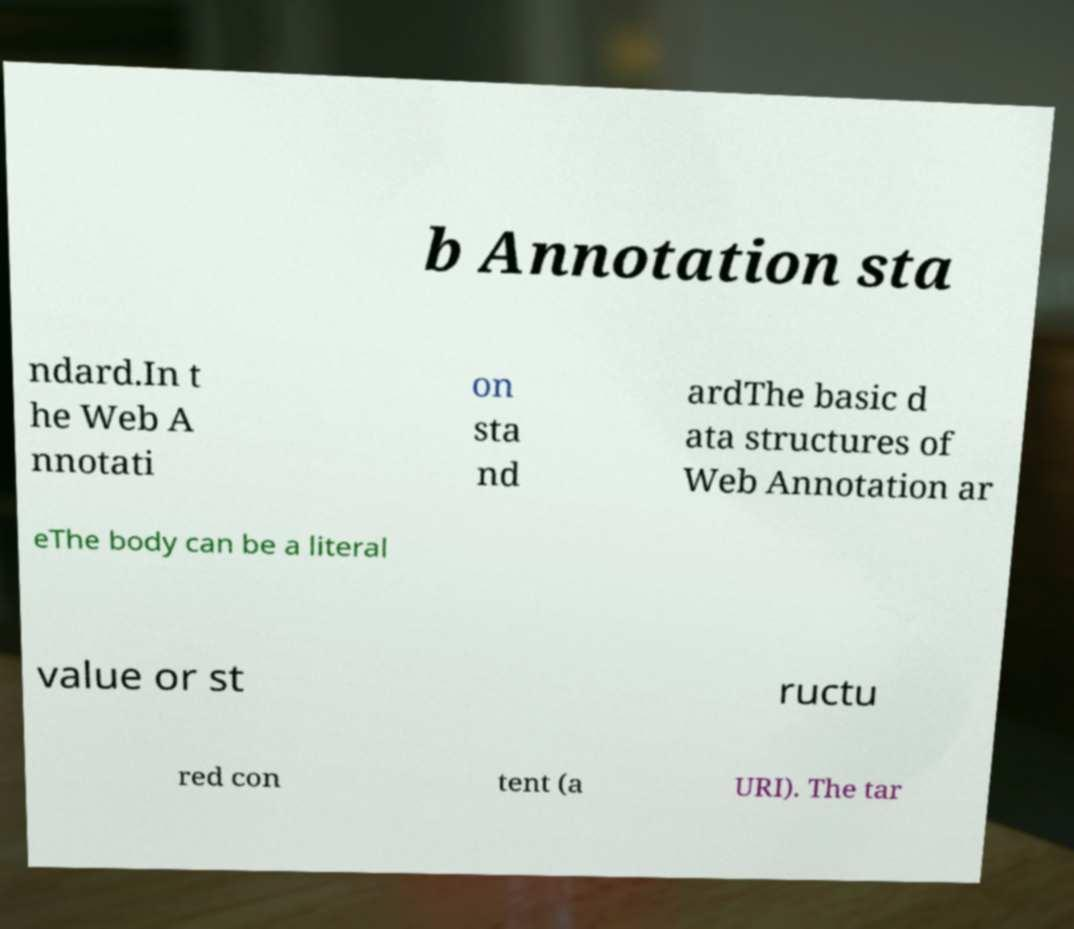Please read and relay the text visible in this image. What does it say? b Annotation sta ndard.In t he Web A nnotati on sta nd ardThe basic d ata structures of Web Annotation ar eThe body can be a literal value or st ructu red con tent (a URI). The tar 